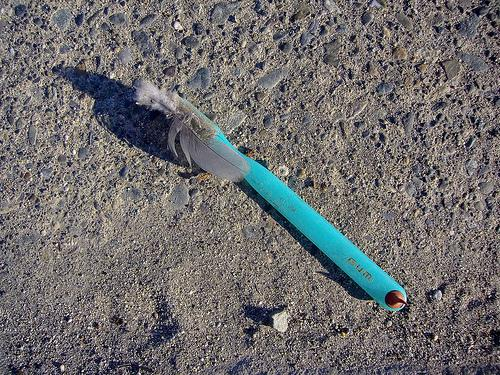Express the appearance of the feather and its relation to the toothbrush using vivid adjectives. A gray bird feather with fluffy and smooth ends is covering the toothbrush bristles. How many objects are associated with the toothbrush in the image? There are at least 3 objects associated with the toothbrush: a bird feather, a rubber gum cleaner, and the gold-lettered company name. Explain the connection between the toothbrush and a specific company, as mentioned in the descriptions. The name of the company is displayed in gold lettering on the toothbrush, indicating it might be a branded product with a Gum logo. Describe the sentiment evoked by the image, considering the condition of the toothbrush. The image conveys a sense of abandonment and uncleanliness, as the dirty toothbrush is left on the rough surface amid dirt and debris. What kind of surface is in the background of the image, and describe the objects embedded in it. The background features a gray and rough concrete surface, with rocks embedded in it and a black triangular oily spot. Explain how the toothbrush is visually represented in the context of its surroundings. The blue toothbrush is laying in the dirt, surrounded by rocks, pebbles, and grains of sand, with a feather stuck to its head. What type of object is lying on the surface, and what color is it? A turquoise toothbrush is lying on the gray and rough surface. Count the number of pebbles mentioned in the image descriptions. There are at least 3 pebbles in the image: a gray one, a white one, and another one in the dirt. Identify the unusual feature on the end of the toothbrush and describe its appearance. There is a pointy rubber tip on the end of the toothbrush that functions as a gum cleaner. Analyze the interaction between the toothbrush and the feather, and describe the resulting condition of the toothbrush. The feather is covering the toothbrush bristles, resulting in a dirty toothbrush with the bristles concealed or obstructed by the feather. Is the toothbrush lying on soft sand or a hard concrete surface? The toothbrush is lying on a hard concrete surface with some grains of sand. What color is the toothbrush in the image? Turquoise Does the feather in the image appear to be smooth or rough? Smooth Is the toothbrush in the image lying on the ground or neatly stored on a shelf? Lying on the ground Describe the pebble close to the toothbrush in the image. The pebble is gray, reflecting light over its shadow, and embedded in the dirt. Determine if the toothbrush in the image belongs to a specific company. Yes, the toothbrush has a gum logo. Create a sentence that combines the toothbrush and feather elements of the image. A dirty turquoise toothbrush with a gum logo lies abandoned on a rough concrete surface, its bristles partially obscured by a gray bird feather. Which phrase best describes the toothbrush in the image? a) clean and unused b) dirty and in the dirt c) neatly stored on a shelf b) dirty and in the dirt Describe the surface where the toothbrush is placed. The toothbrush is placed on a gray and rough surface with rocks embedded in concrete and grains of sand. Are any objects partially covering the bristles of the toothbrush? Yes, a feather is covering the toothbrush bristles. What type of object is covering the toothbrush bristles? A gray bird feather Describe the scene and emotion that is conveyed in the image. The image depicts a neglected turquoise toothbrush with a feather stuck to its bristles, giving off a sense of abandonment and messiness. Is the blue toothbrush laying in the dirt or on a clean surface? The blue toothbrush is laying in the dirt. Which end of the toothbrush has the pointy rubber tip? The end of the toothbrush has the pointy rubber tip. Identify any logos or text shown in the image. There is a gum logo in gold lettering on the toothbrush. Explain the appearance and condition of the toothbrush. The turquoise toothbrush is dirty, lying on the ground, has a pointy rubber tip, a gum logo in gold lettering, and a feather covering its bristles. Explain the components and layout of the diagram. There is no diagram in the image. 